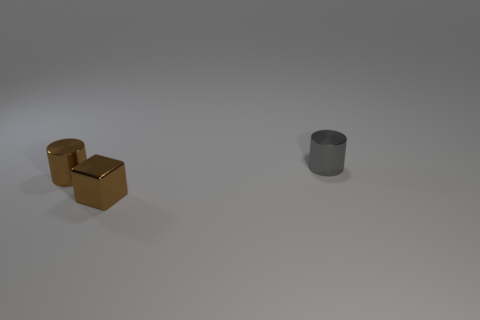Add 3 brown objects. How many objects exist? 6 Subtract all cylinders. How many objects are left? 1 Subtract all brown metal cylinders. Subtract all brown cylinders. How many objects are left? 1 Add 3 gray cylinders. How many gray cylinders are left? 4 Add 1 tiny brown cylinders. How many tiny brown cylinders exist? 2 Subtract 0 cyan cylinders. How many objects are left? 3 